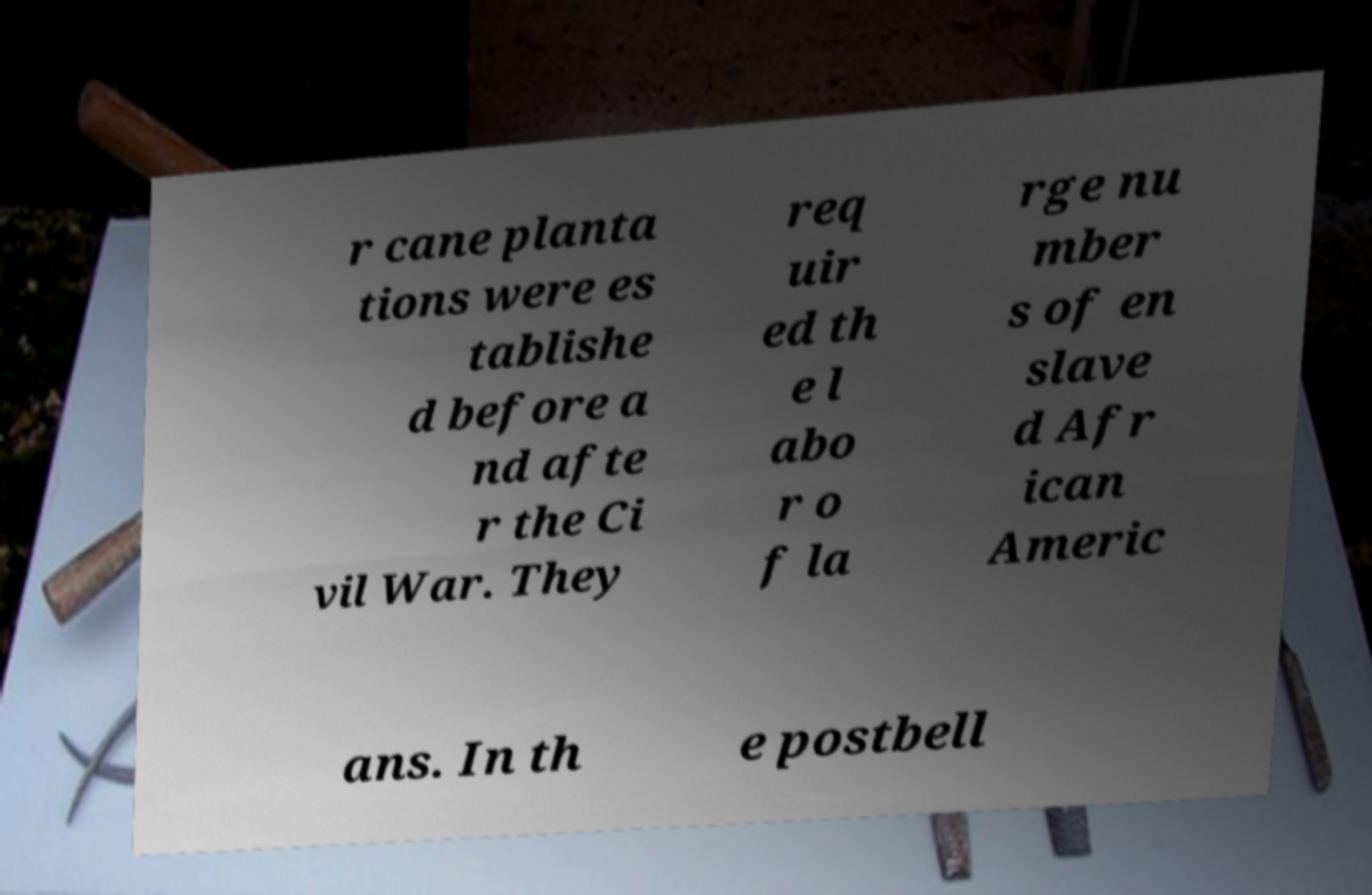Could you extract and type out the text from this image? r cane planta tions were es tablishe d before a nd afte r the Ci vil War. They req uir ed th e l abo r o f la rge nu mber s of en slave d Afr ican Americ ans. In th e postbell 